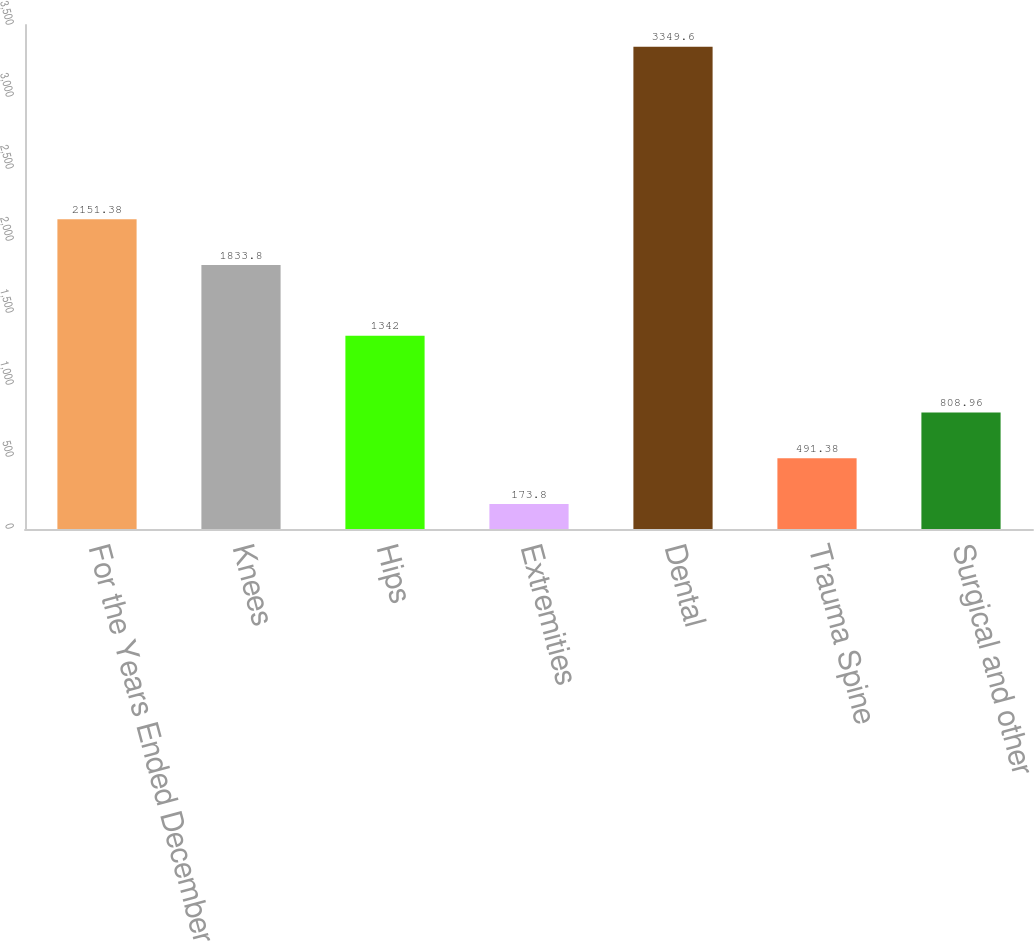<chart> <loc_0><loc_0><loc_500><loc_500><bar_chart><fcel>For the Years Ended December<fcel>Knees<fcel>Hips<fcel>Extremities<fcel>Dental<fcel>Trauma Spine<fcel>Surgical and other<nl><fcel>2151.38<fcel>1833.8<fcel>1342<fcel>173.8<fcel>3349.6<fcel>491.38<fcel>808.96<nl></chart> 